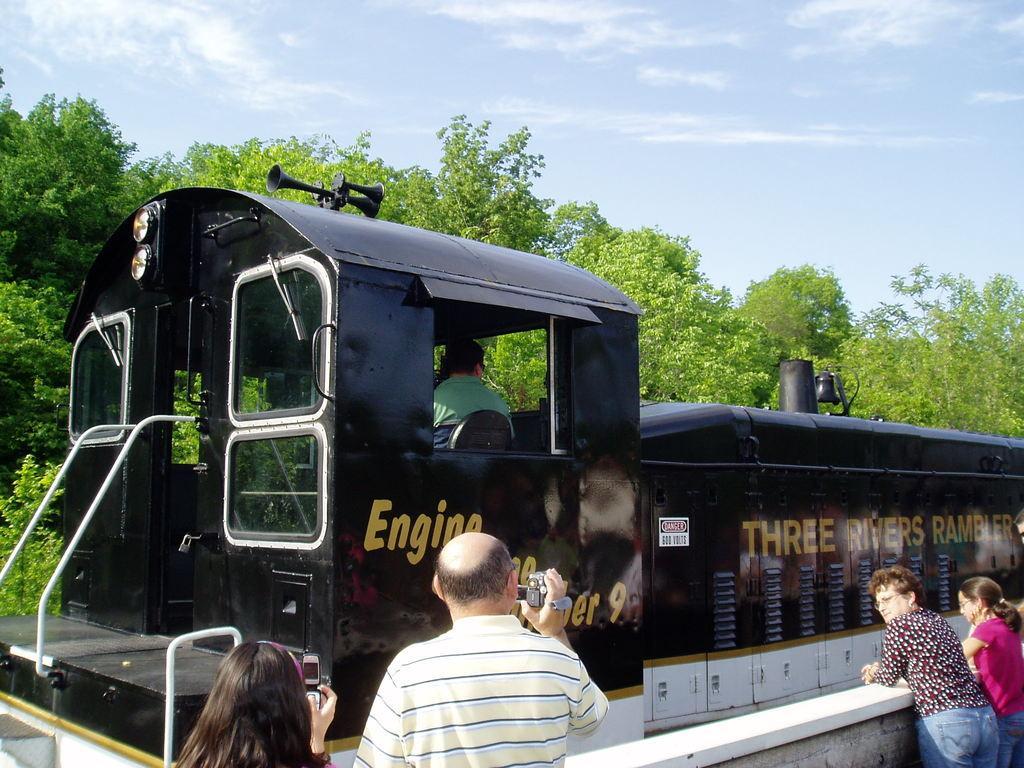How would you summarize this image in a sentence or two? In this image I can see a train engine in black color, at the bottom a man is standing and shooting with the camera, he wore t-shirt beside him there is a girl. On the right side two girls are standing. At the back side there are trees, at the top it is the sky. 